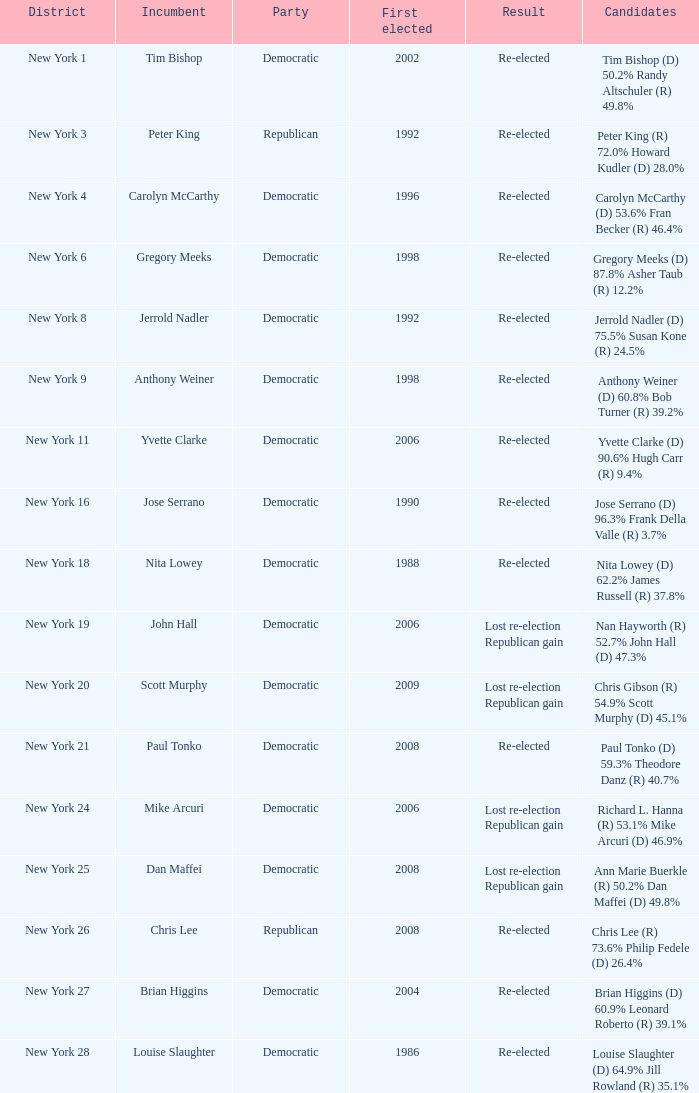What is the total count of parties for richard l. hanna (r) with 53.1% and mike arcuri (d) with 46.9%? 1.0. 